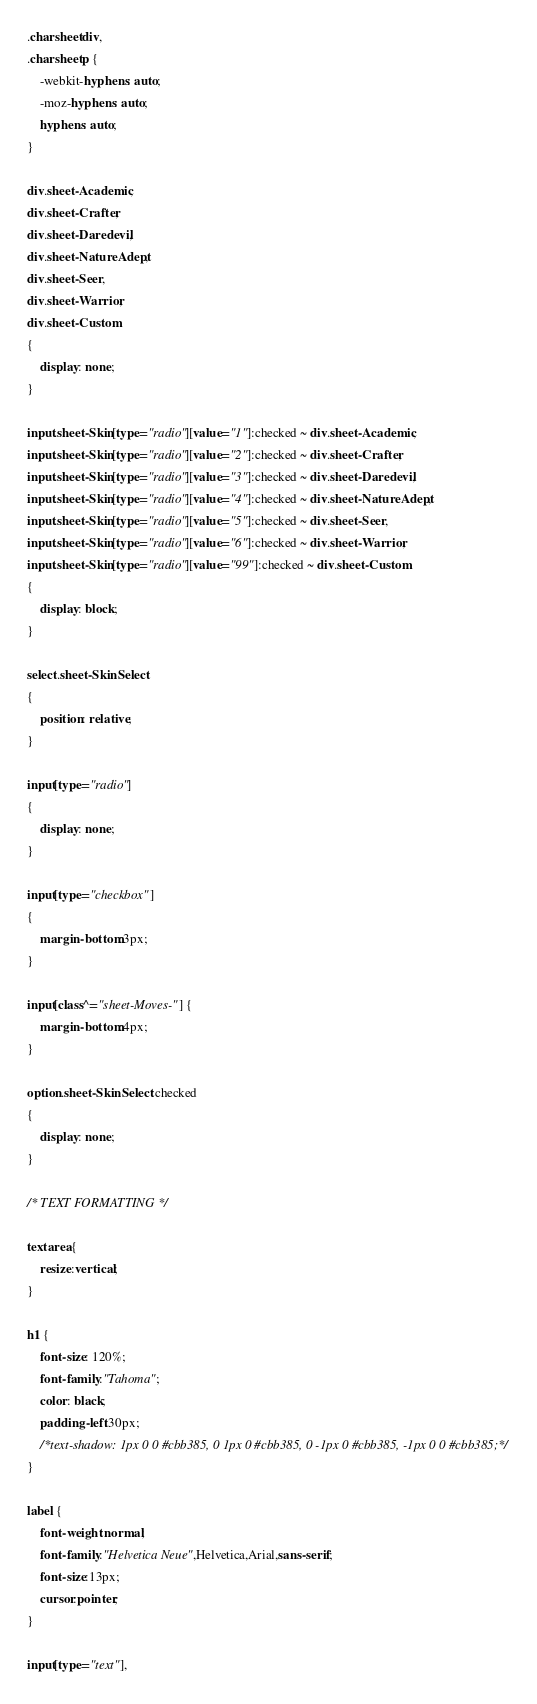Convert code to text. <code><loc_0><loc_0><loc_500><loc_500><_CSS_>.charsheet div,
.charsheet p {
    -webkit-hyphens: auto;
    -moz-hyphens: auto;
    hyphens: auto;
}

div.sheet-Academic,
div.sheet-Crafter,
div.sheet-Daredevil,
div.sheet-NatureAdept,
div.sheet-Seer,
div.sheet-Warrior,
div.sheet-Custom
{
    display: none;
}

input.sheet-Skin[type="radio"][value="1"]:checked ~ div.sheet-Academic,
input.sheet-Skin[type="radio"][value="2"]:checked ~ div.sheet-Crafter,
input.sheet-Skin[type="radio"][value="3"]:checked ~ div.sheet-Daredevil,
input.sheet-Skin[type="radio"][value="4"]:checked ~ div.sheet-NatureAdept,
input.sheet-Skin[type="radio"][value="5"]:checked ~ div.sheet-Seer,
input.sheet-Skin[type="radio"][value="6"]:checked ~ div.sheet-Warrior,
input.sheet-Skin[type="radio"][value="99"]:checked ~ div.sheet-Custom
{
    display: block;
}

select.sheet-SkinSelect 
{
    position: relative;
}

input[type="radio"] 
{
    display: none;
}

input[type="checkbox"] 
{
    margin-bottom:3px;
}

input[class^="sheet-Moves-"] {
    margin-bottom:4px;
}

option.sheet-SkinSelect:checked   
{
    display: none;
}

/* TEXT FORMATTING */

textarea {
    resize:vertical;
}

h1 {
    font-size: 120%;
    font-family:"Tahoma";
    color: black;
    padding-left:30px;
    /*text-shadow: 1px 0 0 #cbb385, 0 1px 0 #cbb385, 0 -1px 0 #cbb385, -1px 0 0 #cbb385;*/
}

label {
    font-weight:normal;
    font-family:"Helvetica Neue",Helvetica,Arial,sans-serif;
    font-size:13px;
    cursor:pointer;
}

input[type="text"],</code> 